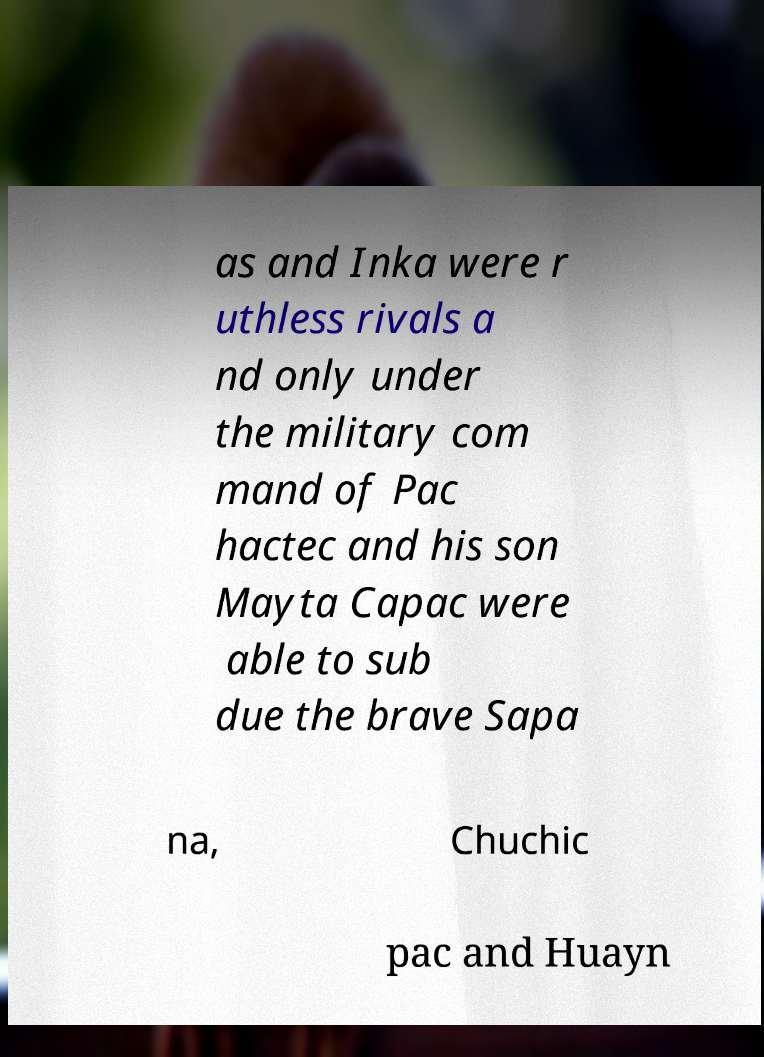Please identify and transcribe the text found in this image. as and Inka were r uthless rivals a nd only under the military com mand of Pac hactec and his son Mayta Capac were able to sub due the brave Sapa na, Chuchic pac and Huayn 